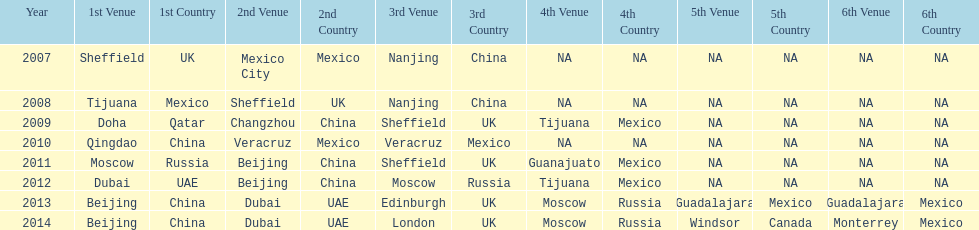Which is the only year that mexico is on a venue 2007. I'm looking to parse the entire table for insights. Could you assist me with that? {'header': ['Year', '1st Venue', '1st Country', '2nd Venue', '2nd Country', '3rd Venue', '3rd Country', '4th Venue', '4th Country', '5th Venue', '5th Country', '6th Venue', '6th Country'], 'rows': [['2007', 'Sheffield', 'UK', 'Mexico City', 'Mexico', 'Nanjing', 'China', 'NA', 'NA', 'NA', 'NA', 'NA', 'NA'], ['2008', 'Tijuana', 'Mexico', 'Sheffield', 'UK', 'Nanjing', 'China', 'NA', 'NA', 'NA', 'NA', 'NA', 'NA'], ['2009', 'Doha', 'Qatar', 'Changzhou', 'China', 'Sheffield', 'UK', 'Tijuana', 'Mexico', 'NA', 'NA', 'NA', 'NA'], ['2010', 'Qingdao', 'China', 'Veracruz', 'Mexico', 'Veracruz', 'Mexico', 'NA', 'NA', 'NA', 'NA', 'NA', 'NA'], ['2011', 'Moscow', 'Russia', 'Beijing', 'China', 'Sheffield', 'UK', 'Guanajuato', 'Mexico', 'NA', 'NA', 'NA', 'NA'], ['2012', 'Dubai', 'UAE', 'Beijing', 'China', 'Moscow', 'Russia', 'Tijuana', 'Mexico', 'NA', 'NA', 'NA', 'NA'], ['2013', 'Beijing', 'China', 'Dubai', 'UAE', 'Edinburgh', 'UK', 'Moscow', 'Russia', 'Guadalajara', 'Mexico', 'Guadalajara', 'Mexico'], ['2014', 'Beijing', 'China', 'Dubai', 'UAE', 'London', 'UK', 'Moscow', 'Russia', 'Windsor', 'Canada', 'Monterrey', 'Mexico']]} 